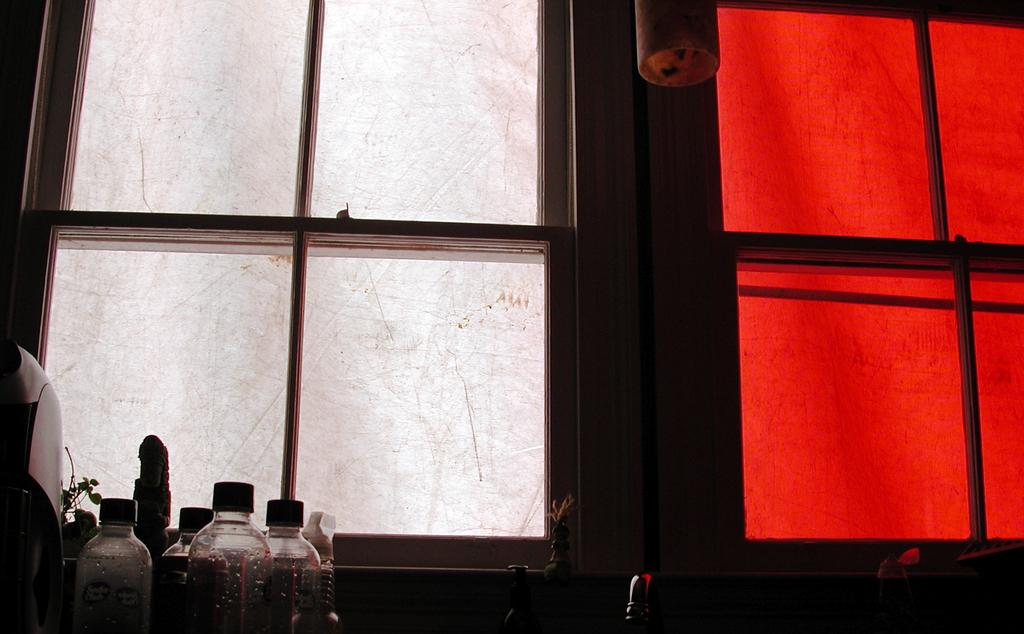What colors are present on the windows in the image? The windows in the image have white and red colors. What can be seen on the left side of the image? There are bottles on the left side of the image. Can you tell me how many actors are performing in the image? There are no actors present in the image; it features windows with white and red colors and bottles on the left side. What type of frog can be seen sitting on the windowsill in the image? There is no frog present in the image. 